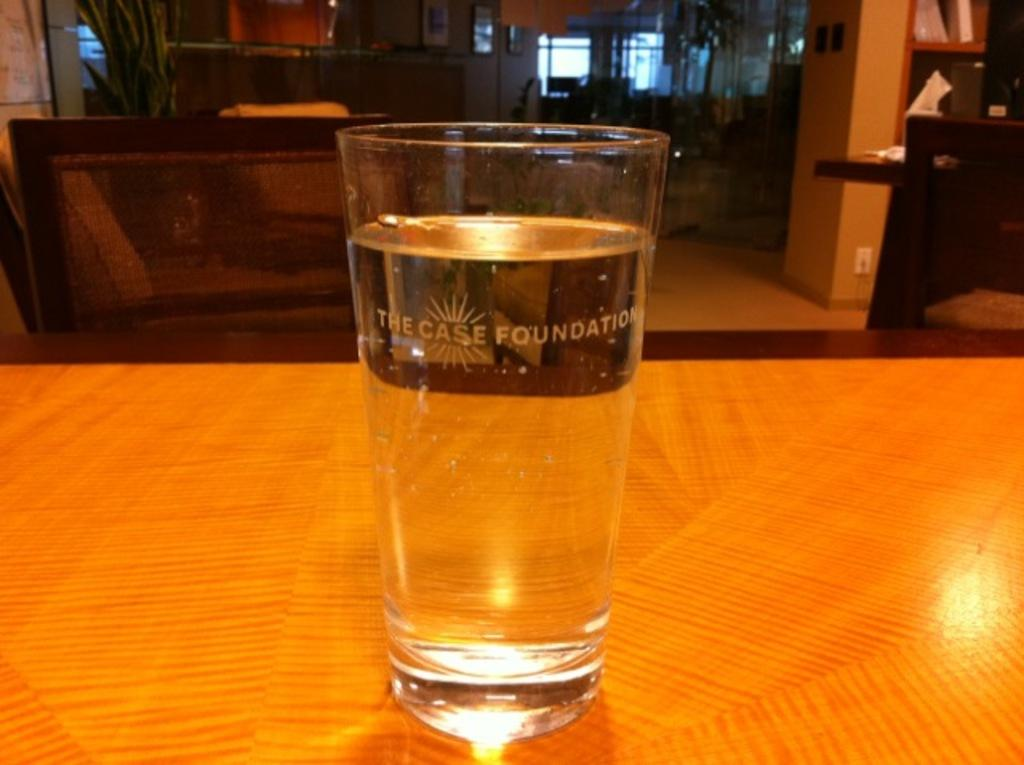What is placed on the table in the image? There is a glass of water in the image. Can you describe the contents of the glass? The glass contains water. What type of cook is preparing the balls in the image? There is no cook or balls present in the image; it only features a glass of water placed on a table. 